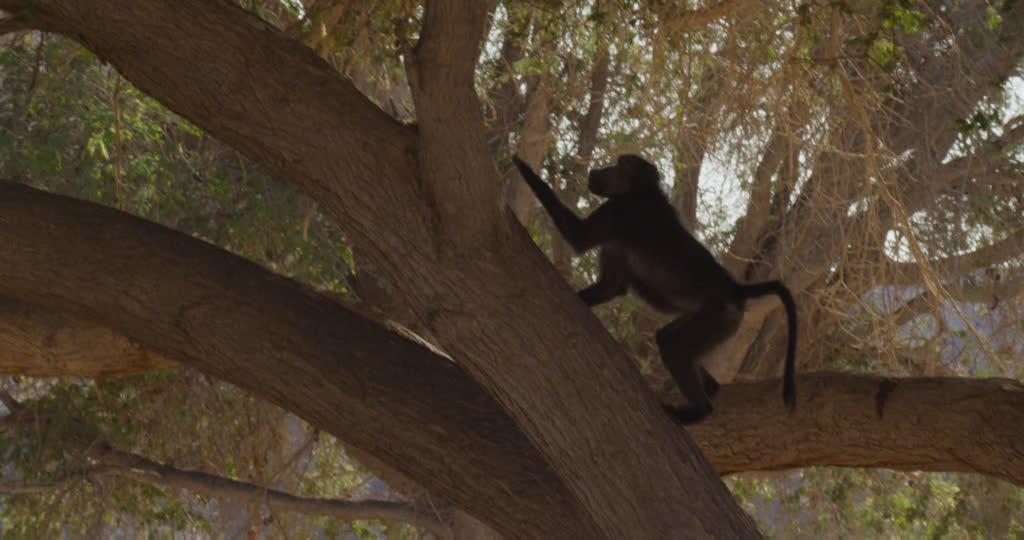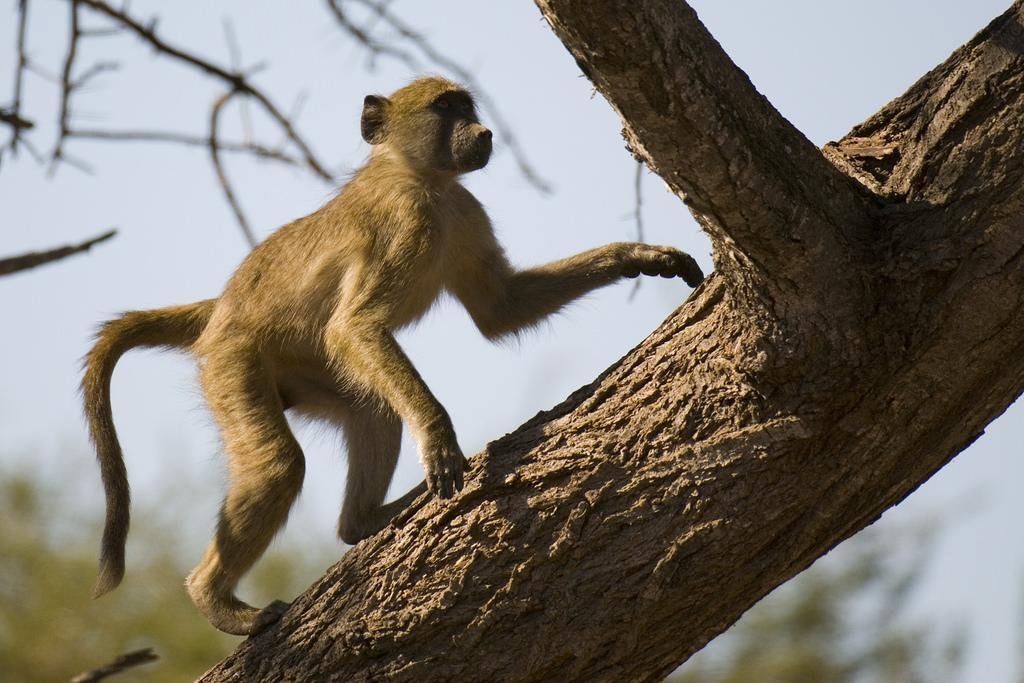The first image is the image on the left, the second image is the image on the right. Examine the images to the left and right. Is the description "The monkeys are actively climbing trees." accurate? Answer yes or no. Yes. The first image is the image on the left, the second image is the image on the right. For the images displayed, is the sentence "at least two baboons are climbimg a tree in the image pair" factually correct? Answer yes or no. Yes. 